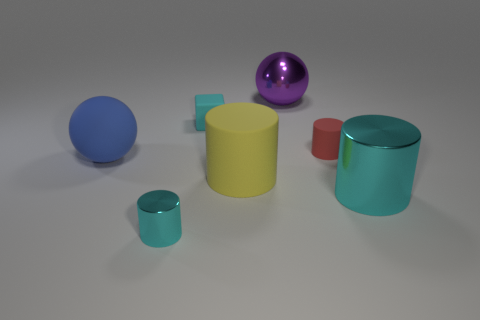The big object that is both on the left side of the large metal cylinder and in front of the large blue thing is made of what material?
Offer a terse response. Rubber. There is a blue thing that is made of the same material as the red object; what shape is it?
Ensure brevity in your answer.  Sphere. Is there any other thing that has the same color as the small shiny object?
Offer a terse response. Yes. Is the number of blocks that are left of the large rubber sphere greater than the number of big purple balls?
Give a very brief answer. No. What is the material of the tiny red object?
Your answer should be very brief. Rubber. What number of metal cylinders have the same size as the blue matte thing?
Ensure brevity in your answer.  1. Is the number of purple spheres that are in front of the small rubber cylinder the same as the number of blue rubber balls that are on the left side of the blue rubber sphere?
Give a very brief answer. Yes. Is the red thing made of the same material as the big purple object?
Ensure brevity in your answer.  No. Is there a blue object to the right of the metallic cylinder that is in front of the large cyan cylinder?
Provide a succinct answer. No. Are there any other small things of the same shape as the small shiny object?
Offer a very short reply. Yes. 